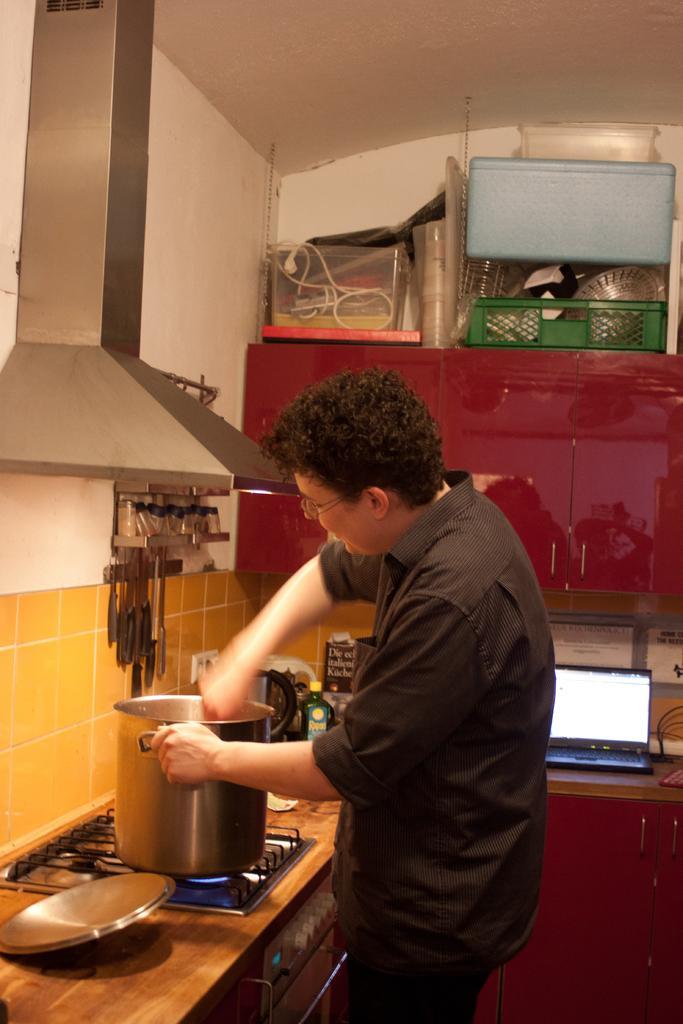Can you describe this image briefly? This is the picture of a kitchen room. In this picture we can see objects on the cupboards, platform. In this picture we can see a person is cooking. We can see the container on the stove. We can see the spoons are hanging to the hooks of the stand. We can see a laptop. 